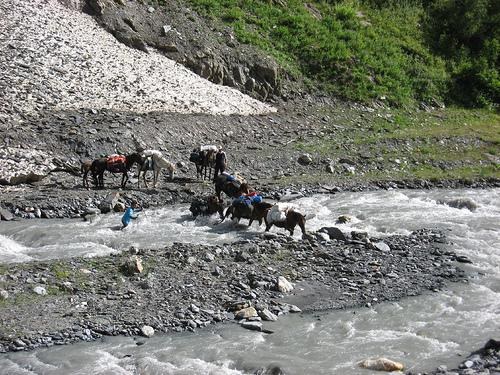Where are these animals located? river 